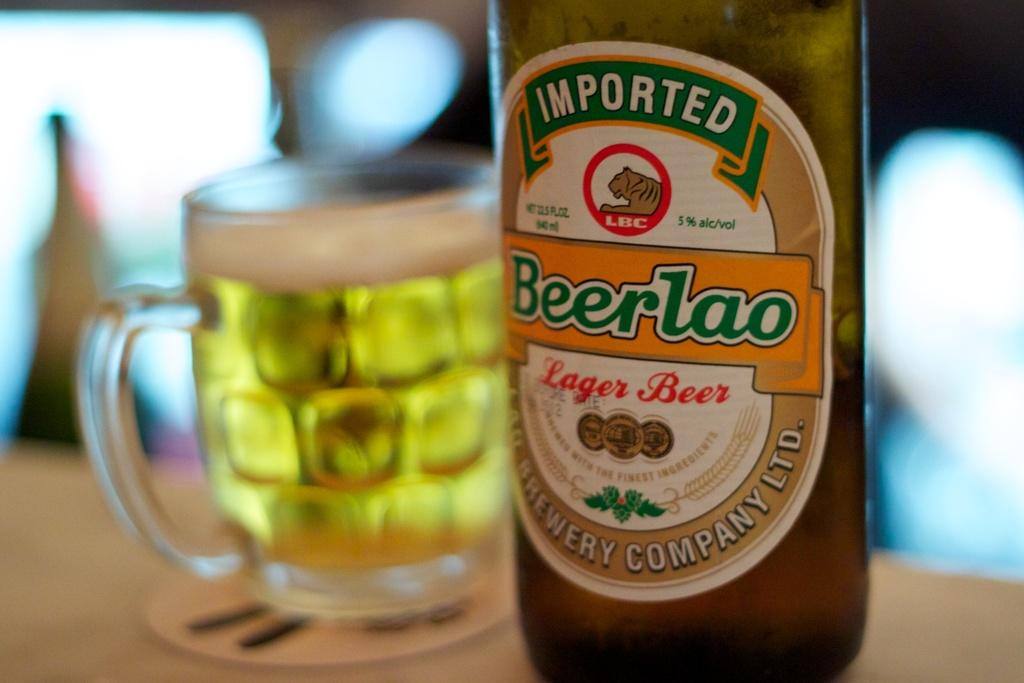<image>
Share a concise interpretation of the image provided. Bottle of a  22.3 fluid ounce Imported Beerlao Lager Beer. 